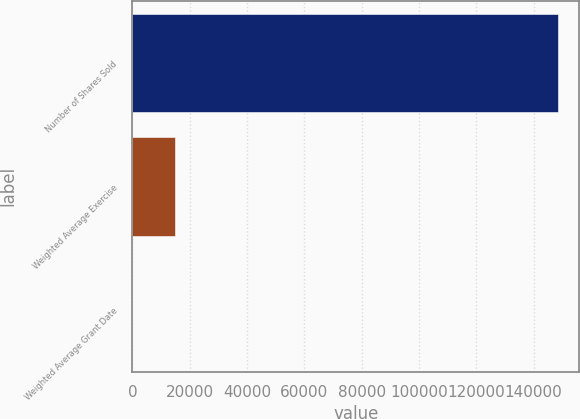Convert chart. <chart><loc_0><loc_0><loc_500><loc_500><bar_chart><fcel>Number of Shares Sold<fcel>Weighted Average Exercise<fcel>Weighted Average Grant Date<nl><fcel>148490<fcel>14854.1<fcel>5.72<nl></chart> 